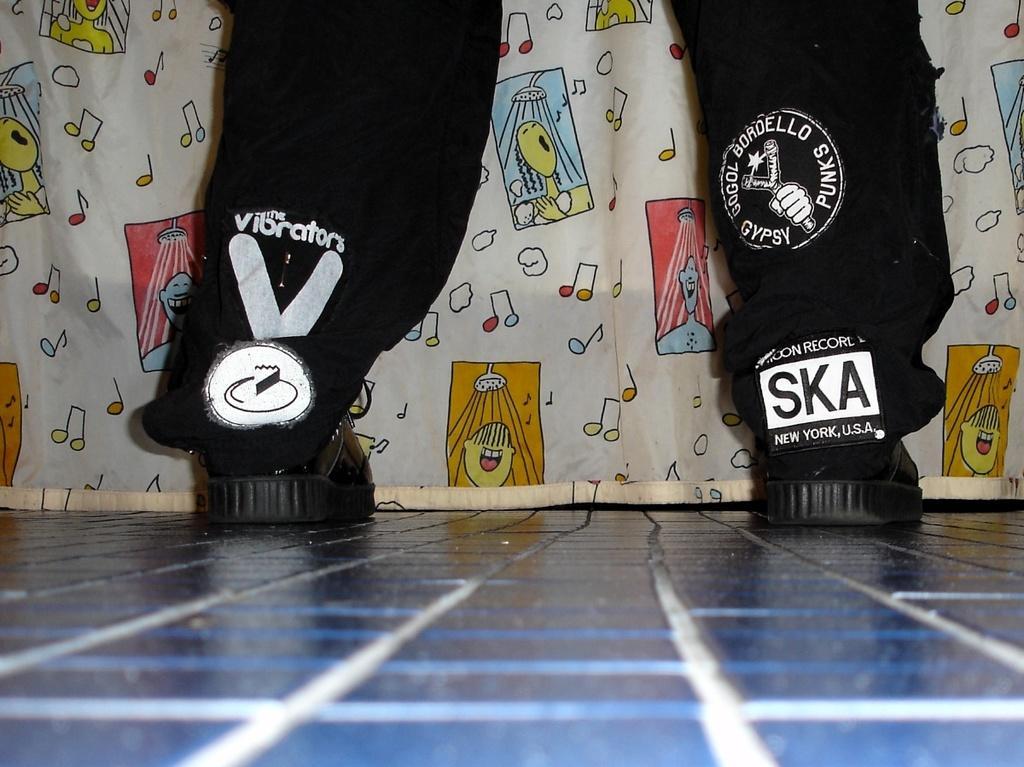In one or two sentences, can you explain what this image depicts? In this picture we can see a person legs on the floor and in the background we can see a cloth. 